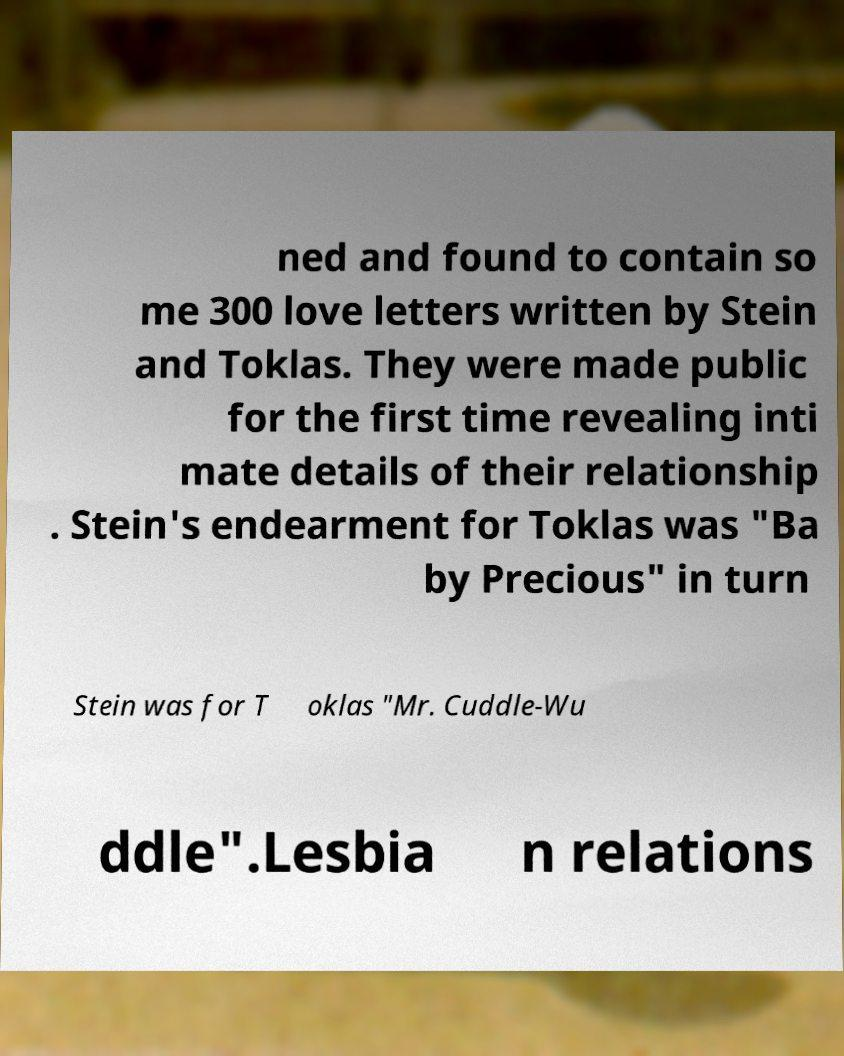Can you read and provide the text displayed in the image?This photo seems to have some interesting text. Can you extract and type it out for me? ned and found to contain so me 300 love letters written by Stein and Toklas. They were made public for the first time revealing inti mate details of their relationship . Stein's endearment for Toklas was "Ba by Precious" in turn Stein was for T oklas "Mr. Cuddle-Wu ddle".Lesbia n relations 